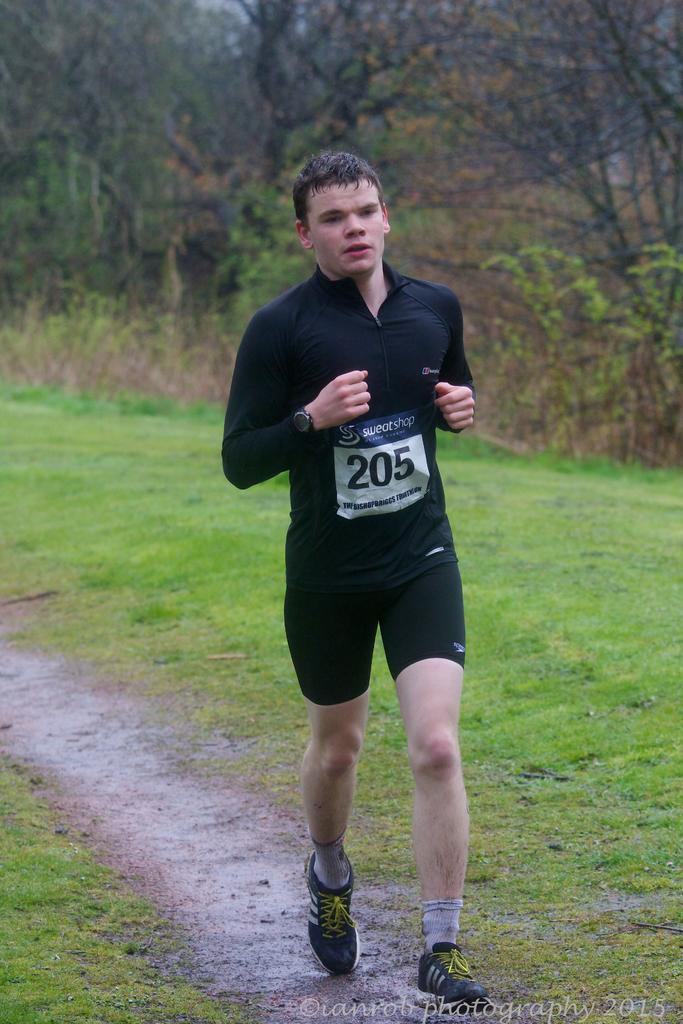In one or two sentences, can you explain what this image depicts? In this image a person is running on the path. Background there are few plants and trees on the grassland. 